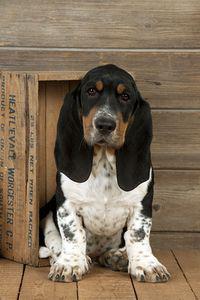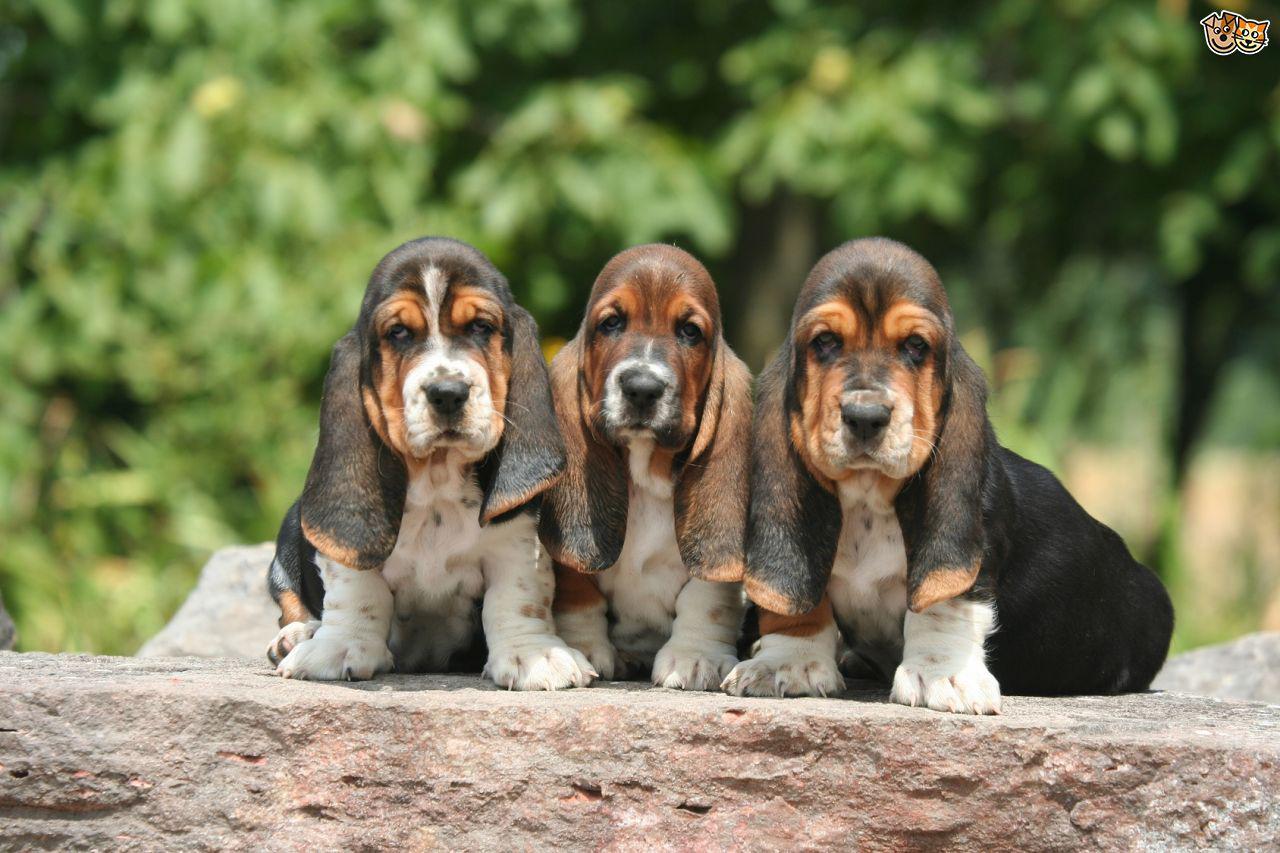The first image is the image on the left, the second image is the image on the right. Examine the images to the left and right. Is the description "In one of the images, a basset hound is among colorful yellow leaves" accurate? Answer yes or no. No. The first image is the image on the left, the second image is the image on the right. Assess this claim about the two images: "There are three hounds in the right image.". Correct or not? Answer yes or no. Yes. 